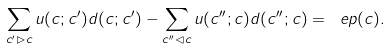Convert formula to latex. <formula><loc_0><loc_0><loc_500><loc_500>\sum _ { c ^ { \prime } \rhd c } u ( c ; c ^ { \prime } ) d ( c ; c ^ { \prime } ) - \sum _ { c ^ { \prime \prime } \lhd c } u ( c ^ { \prime \prime } ; c ) d ( c ^ { \prime \prime } ; c ) = \ e p ( c ) .</formula> 